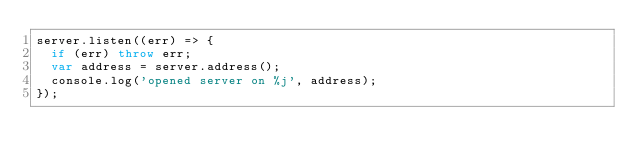Convert code to text. <code><loc_0><loc_0><loc_500><loc_500><_JavaScript_>server.listen((err) => {
  if (err) throw err;
  var address = server.address();
  console.log('opened server on %j', address);
});</code> 